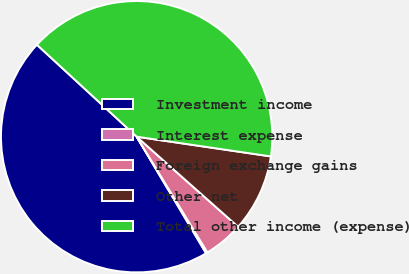Convert chart. <chart><loc_0><loc_0><loc_500><loc_500><pie_chart><fcel>Investment income<fcel>Interest expense<fcel>Foreign exchange gains<fcel>Other net<fcel>Total other income (expense)<nl><fcel>45.4%<fcel>0.19%<fcel>4.71%<fcel>9.23%<fcel>40.47%<nl></chart> 